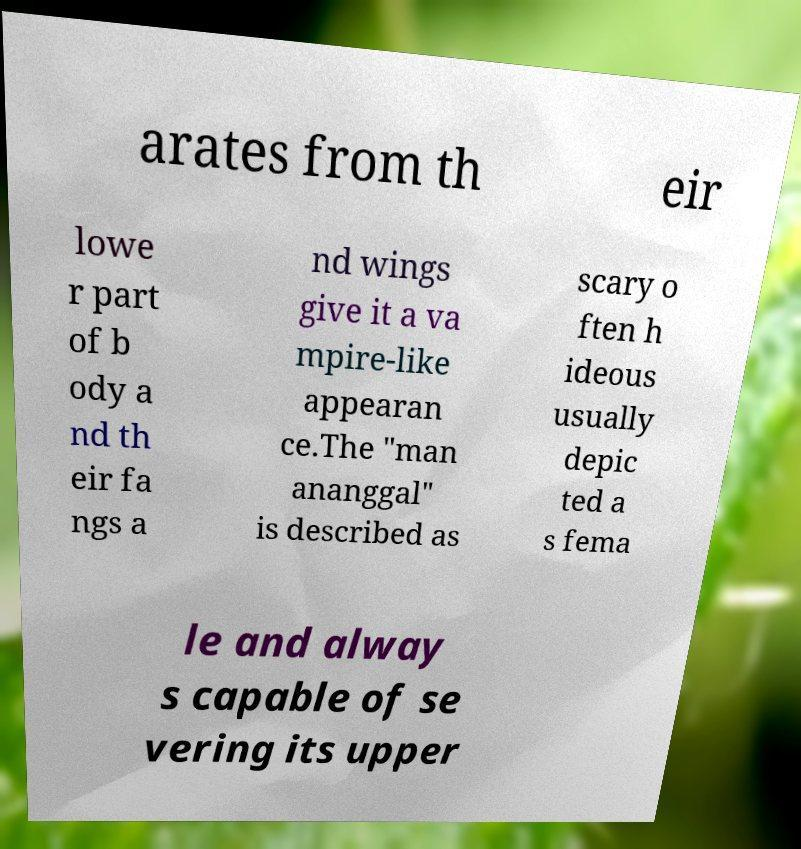Can you accurately transcribe the text from the provided image for me? arates from th eir lowe r part of b ody a nd th eir fa ngs a nd wings give it a va mpire-like appearan ce.The "man ananggal" is described as scary o ften h ideous usually depic ted a s fema le and alway s capable of se vering its upper 